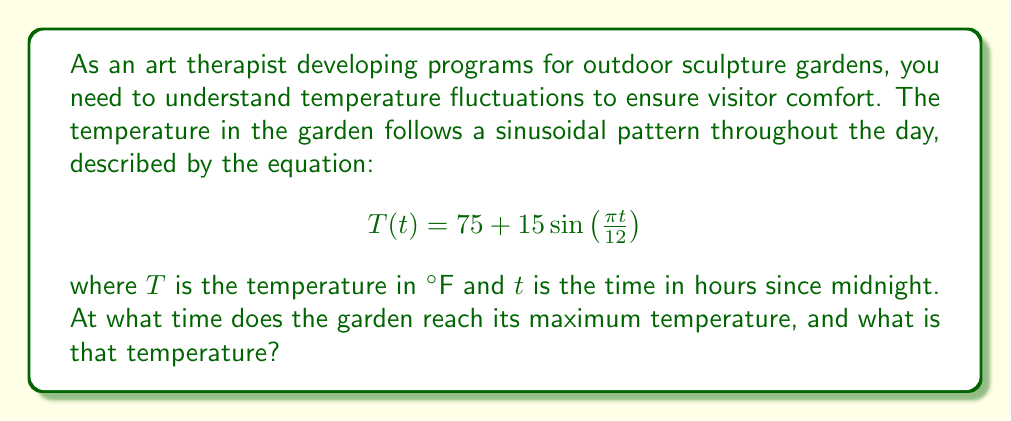Show me your answer to this math problem. To solve this problem, we'll follow these steps:

1) The given equation is in the form of a sine function:
   $$T(t) = A + B\sin\left(\frac{2\pi}{P}t\right)$$
   where $A$ is the average temperature, $B$ is the amplitude, and $P$ is the period.

2) In our case:
   $A = 75$ (average temperature)
   $B = 15$ (amplitude)
   $P = 24$ (period, as the cycle repeats daily)

3) The sine function reaches its maximum when the argument is $\frac{\pi}{2}$ (or 90°). So we need to solve:

   $$\frac{\pi t}{12} = \frac{\pi}{2}$$

4) Solving for $t$:
   $$t = 12 \cdot \frac{1}{2} = 6$$

5) This means the maximum temperature occurs 6 hours after midnight, or at 6:00 AM.

6) To find the maximum temperature, we substitute $t = 6$ into the original equation:

   $$T(6) = 75 + 15\sin\left(\frac{\pi \cdot 6}{12}\right) = 75 + 15\sin\left(\frac{\pi}{2}\right) = 75 + 15 = 90$$

Therefore, the maximum temperature is 90°F and occurs at 6:00 AM.
Answer: 6:00 AM, 90°F 